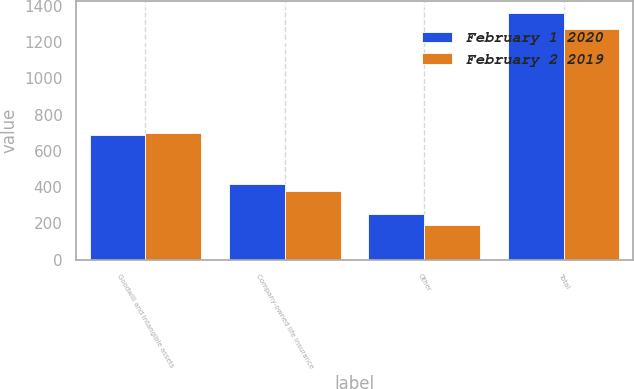<chart> <loc_0><loc_0><loc_500><loc_500><stacked_bar_chart><ecel><fcel>Goodwill and intangible assets<fcel>Company-owned life insurance<fcel>Other<fcel>Total<nl><fcel>February 1 2020<fcel>686<fcel>418<fcel>254<fcel>1358<nl><fcel>February 2 2019<fcel>699<fcel>380<fcel>194<fcel>1273<nl></chart> 